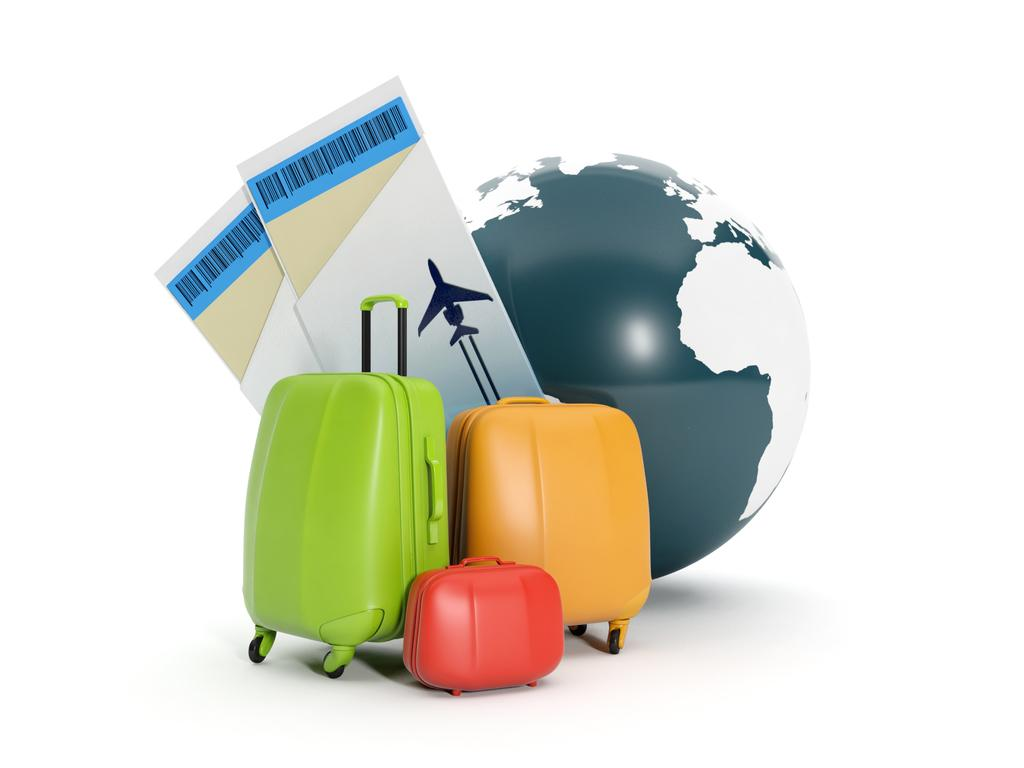What is the main object in the image? There is a globe in the image. What else can be seen in the image related to travel? There are luggage bags and air tickets in the image. How does the grandmother feel about the travel plans in the image? There is no mention of a grandmother or any feelings in the image; it only shows a globe, luggage bags, and air tickets. 